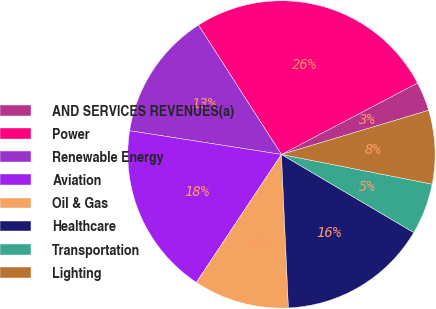<chart> <loc_0><loc_0><loc_500><loc_500><pie_chart><fcel>AND SERVICES REVENUES(a)<fcel>Power<fcel>Renewable Energy<fcel>Aviation<fcel>Oil & Gas<fcel>Healthcare<fcel>Transportation<fcel>Lighting<nl><fcel>3.06%<fcel>26.38%<fcel>13.46%<fcel>18.13%<fcel>10.06%<fcel>15.79%<fcel>5.39%<fcel>7.73%<nl></chart> 